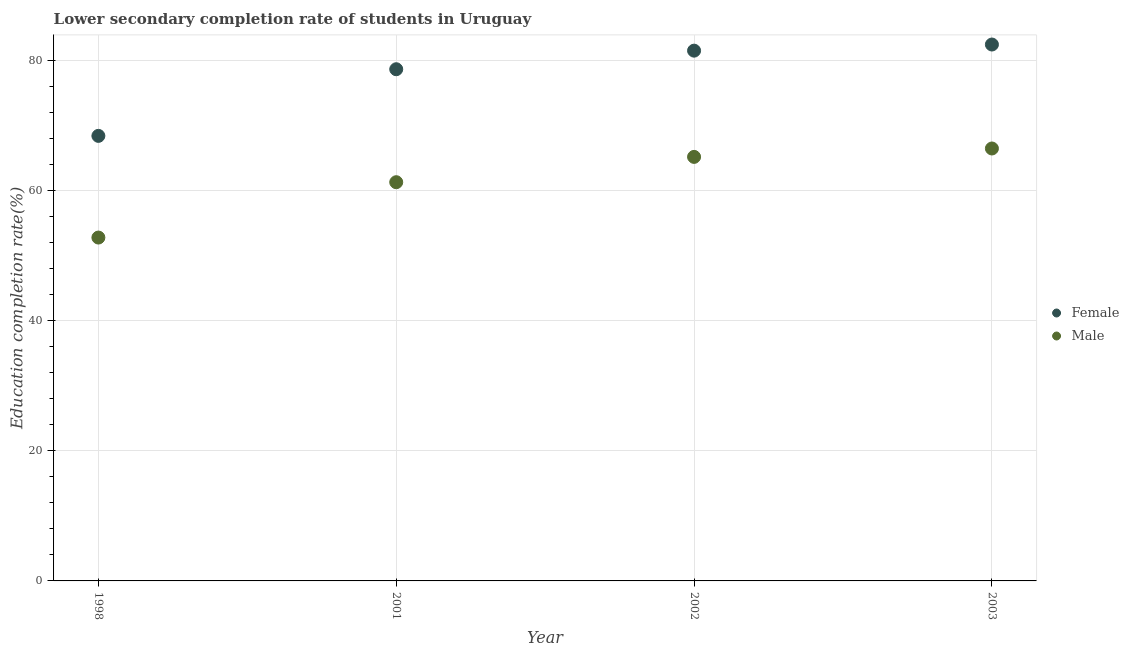What is the education completion rate of female students in 2003?
Your answer should be compact. 82.45. Across all years, what is the maximum education completion rate of female students?
Provide a short and direct response. 82.45. Across all years, what is the minimum education completion rate of male students?
Your response must be concise. 52.78. In which year was the education completion rate of male students maximum?
Your answer should be compact. 2003. In which year was the education completion rate of female students minimum?
Ensure brevity in your answer.  1998. What is the total education completion rate of male students in the graph?
Provide a succinct answer. 245.7. What is the difference between the education completion rate of female students in 1998 and that in 2002?
Your response must be concise. -13.1. What is the difference between the education completion rate of female students in 2003 and the education completion rate of male students in 2001?
Provide a succinct answer. 21.16. What is the average education completion rate of male students per year?
Make the answer very short. 61.43. In the year 2003, what is the difference between the education completion rate of female students and education completion rate of male students?
Provide a short and direct response. 15.98. What is the ratio of the education completion rate of female students in 1998 to that in 2001?
Ensure brevity in your answer.  0.87. Is the education completion rate of male students in 2002 less than that in 2003?
Your answer should be compact. Yes. Is the difference between the education completion rate of female students in 2001 and 2002 greater than the difference between the education completion rate of male students in 2001 and 2002?
Offer a very short reply. Yes. What is the difference between the highest and the second highest education completion rate of female students?
Offer a terse response. 0.94. What is the difference between the highest and the lowest education completion rate of male students?
Offer a very short reply. 13.69. Does the education completion rate of male students monotonically increase over the years?
Make the answer very short. Yes. How many dotlines are there?
Your answer should be compact. 2. Are the values on the major ticks of Y-axis written in scientific E-notation?
Provide a succinct answer. No. How are the legend labels stacked?
Offer a very short reply. Vertical. What is the title of the graph?
Your answer should be very brief. Lower secondary completion rate of students in Uruguay. Does "Private funds" appear as one of the legend labels in the graph?
Your answer should be compact. No. What is the label or title of the X-axis?
Provide a short and direct response. Year. What is the label or title of the Y-axis?
Your response must be concise. Education completion rate(%). What is the Education completion rate(%) in Female in 1998?
Offer a very short reply. 68.41. What is the Education completion rate(%) of Male in 1998?
Your answer should be very brief. 52.78. What is the Education completion rate(%) in Female in 2001?
Keep it short and to the point. 78.65. What is the Education completion rate(%) in Male in 2001?
Offer a very short reply. 61.28. What is the Education completion rate(%) in Female in 2002?
Make the answer very short. 81.5. What is the Education completion rate(%) of Male in 2002?
Your answer should be very brief. 65.18. What is the Education completion rate(%) of Female in 2003?
Your response must be concise. 82.45. What is the Education completion rate(%) in Male in 2003?
Offer a very short reply. 66.47. Across all years, what is the maximum Education completion rate(%) of Female?
Your response must be concise. 82.45. Across all years, what is the maximum Education completion rate(%) of Male?
Your answer should be compact. 66.47. Across all years, what is the minimum Education completion rate(%) in Female?
Provide a short and direct response. 68.41. Across all years, what is the minimum Education completion rate(%) of Male?
Your answer should be very brief. 52.78. What is the total Education completion rate(%) of Female in the graph?
Give a very brief answer. 311.01. What is the total Education completion rate(%) in Male in the graph?
Give a very brief answer. 245.7. What is the difference between the Education completion rate(%) in Female in 1998 and that in 2001?
Provide a succinct answer. -10.24. What is the difference between the Education completion rate(%) of Male in 1998 and that in 2001?
Give a very brief answer. -8.51. What is the difference between the Education completion rate(%) of Female in 1998 and that in 2002?
Give a very brief answer. -13.1. What is the difference between the Education completion rate(%) in Male in 1998 and that in 2002?
Your answer should be compact. -12.4. What is the difference between the Education completion rate(%) of Female in 1998 and that in 2003?
Your answer should be very brief. -14.04. What is the difference between the Education completion rate(%) in Male in 1998 and that in 2003?
Your response must be concise. -13.69. What is the difference between the Education completion rate(%) of Female in 2001 and that in 2002?
Offer a terse response. -2.86. What is the difference between the Education completion rate(%) in Male in 2001 and that in 2002?
Your answer should be compact. -3.89. What is the difference between the Education completion rate(%) in Female in 2001 and that in 2003?
Offer a very short reply. -3.8. What is the difference between the Education completion rate(%) of Male in 2001 and that in 2003?
Offer a very short reply. -5.18. What is the difference between the Education completion rate(%) of Female in 2002 and that in 2003?
Offer a terse response. -0.94. What is the difference between the Education completion rate(%) in Male in 2002 and that in 2003?
Ensure brevity in your answer.  -1.29. What is the difference between the Education completion rate(%) in Female in 1998 and the Education completion rate(%) in Male in 2001?
Offer a terse response. 7.12. What is the difference between the Education completion rate(%) in Female in 1998 and the Education completion rate(%) in Male in 2002?
Make the answer very short. 3.23. What is the difference between the Education completion rate(%) in Female in 1998 and the Education completion rate(%) in Male in 2003?
Ensure brevity in your answer.  1.94. What is the difference between the Education completion rate(%) in Female in 2001 and the Education completion rate(%) in Male in 2002?
Your answer should be compact. 13.47. What is the difference between the Education completion rate(%) in Female in 2001 and the Education completion rate(%) in Male in 2003?
Your response must be concise. 12.18. What is the difference between the Education completion rate(%) in Female in 2002 and the Education completion rate(%) in Male in 2003?
Give a very brief answer. 15.04. What is the average Education completion rate(%) of Female per year?
Offer a very short reply. 77.75. What is the average Education completion rate(%) in Male per year?
Offer a terse response. 61.43. In the year 1998, what is the difference between the Education completion rate(%) in Female and Education completion rate(%) in Male?
Provide a succinct answer. 15.63. In the year 2001, what is the difference between the Education completion rate(%) of Female and Education completion rate(%) of Male?
Provide a short and direct response. 17.36. In the year 2002, what is the difference between the Education completion rate(%) in Female and Education completion rate(%) in Male?
Make the answer very short. 16.33. In the year 2003, what is the difference between the Education completion rate(%) in Female and Education completion rate(%) in Male?
Ensure brevity in your answer.  15.98. What is the ratio of the Education completion rate(%) in Female in 1998 to that in 2001?
Your answer should be compact. 0.87. What is the ratio of the Education completion rate(%) in Male in 1998 to that in 2001?
Provide a succinct answer. 0.86. What is the ratio of the Education completion rate(%) in Female in 1998 to that in 2002?
Make the answer very short. 0.84. What is the ratio of the Education completion rate(%) of Male in 1998 to that in 2002?
Offer a terse response. 0.81. What is the ratio of the Education completion rate(%) of Female in 1998 to that in 2003?
Ensure brevity in your answer.  0.83. What is the ratio of the Education completion rate(%) in Male in 1998 to that in 2003?
Keep it short and to the point. 0.79. What is the ratio of the Education completion rate(%) of Female in 2001 to that in 2002?
Offer a terse response. 0.96. What is the ratio of the Education completion rate(%) of Male in 2001 to that in 2002?
Provide a short and direct response. 0.94. What is the ratio of the Education completion rate(%) in Female in 2001 to that in 2003?
Offer a very short reply. 0.95. What is the ratio of the Education completion rate(%) of Male in 2001 to that in 2003?
Your answer should be very brief. 0.92. What is the ratio of the Education completion rate(%) in Female in 2002 to that in 2003?
Make the answer very short. 0.99. What is the ratio of the Education completion rate(%) in Male in 2002 to that in 2003?
Make the answer very short. 0.98. What is the difference between the highest and the second highest Education completion rate(%) of Female?
Offer a very short reply. 0.94. What is the difference between the highest and the second highest Education completion rate(%) in Male?
Give a very brief answer. 1.29. What is the difference between the highest and the lowest Education completion rate(%) in Female?
Provide a succinct answer. 14.04. What is the difference between the highest and the lowest Education completion rate(%) of Male?
Your answer should be very brief. 13.69. 